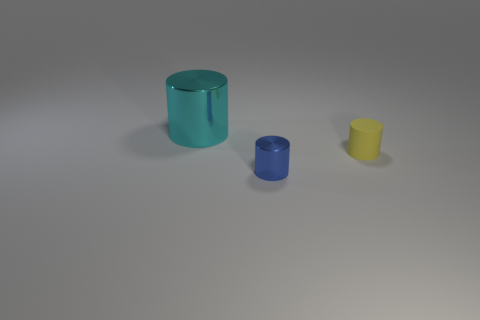Is there anything else that has the same material as the small yellow object?
Provide a short and direct response. No. How many objects are either cyan objects or big yellow matte cylinders?
Your answer should be compact. 1. The blue shiny object is what size?
Provide a short and direct response. Small. Is the number of cyan shiny objects less than the number of small things?
Your response must be concise. Yes. The metal thing to the right of the cyan thing has what shape?
Your response must be concise. Cylinder. There is a metallic cylinder to the left of the blue shiny object; are there any shiny cylinders that are in front of it?
Offer a terse response. Yes. How many yellow objects are the same material as the large cyan thing?
Give a very brief answer. 0. There is a shiny object in front of the object to the left of the metallic cylinder that is on the right side of the big thing; what is its size?
Make the answer very short. Small. How many tiny blue metallic cylinders are in front of the big cyan shiny thing?
Provide a succinct answer. 1. Are there more cyan objects than purple balls?
Ensure brevity in your answer.  Yes. 